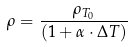Convert formula to latex. <formula><loc_0><loc_0><loc_500><loc_500>\rho = \frac { \rho _ { T _ { 0 } } } { ( 1 + \alpha \cdot \Delta T ) }</formula> 